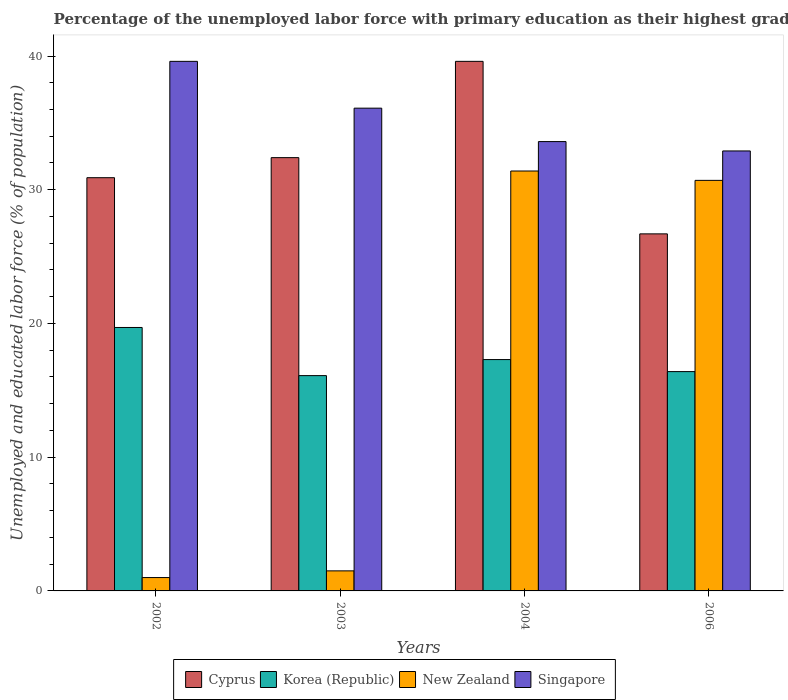How many different coloured bars are there?
Your answer should be compact. 4. How many groups of bars are there?
Your response must be concise. 4. Are the number of bars on each tick of the X-axis equal?
Your answer should be very brief. Yes. How many bars are there on the 1st tick from the right?
Your response must be concise. 4. Across all years, what is the maximum percentage of the unemployed labor force with primary education in New Zealand?
Give a very brief answer. 31.4. Across all years, what is the minimum percentage of the unemployed labor force with primary education in Cyprus?
Your answer should be compact. 26.7. What is the total percentage of the unemployed labor force with primary education in Korea (Republic) in the graph?
Ensure brevity in your answer.  69.5. What is the difference between the percentage of the unemployed labor force with primary education in Singapore in 2002 and that in 2004?
Ensure brevity in your answer.  6. What is the difference between the percentage of the unemployed labor force with primary education in Cyprus in 2003 and the percentage of the unemployed labor force with primary education in New Zealand in 2002?
Provide a short and direct response. 31.4. What is the average percentage of the unemployed labor force with primary education in Cyprus per year?
Make the answer very short. 32.4. In the year 2002, what is the difference between the percentage of the unemployed labor force with primary education in Korea (Republic) and percentage of the unemployed labor force with primary education in Singapore?
Your answer should be compact. -19.9. What is the ratio of the percentage of the unemployed labor force with primary education in Cyprus in 2002 to that in 2006?
Give a very brief answer. 1.16. Is the percentage of the unemployed labor force with primary education in Korea (Republic) in 2002 less than that in 2003?
Offer a terse response. No. Is the difference between the percentage of the unemployed labor force with primary education in Korea (Republic) in 2004 and 2006 greater than the difference between the percentage of the unemployed labor force with primary education in Singapore in 2004 and 2006?
Your response must be concise. Yes. What is the difference between the highest and the second highest percentage of the unemployed labor force with primary education in Korea (Republic)?
Make the answer very short. 2.4. What is the difference between the highest and the lowest percentage of the unemployed labor force with primary education in Cyprus?
Offer a very short reply. 12.9. Is the sum of the percentage of the unemployed labor force with primary education in New Zealand in 2004 and 2006 greater than the maximum percentage of the unemployed labor force with primary education in Korea (Republic) across all years?
Your response must be concise. Yes. Is it the case that in every year, the sum of the percentage of the unemployed labor force with primary education in Cyprus and percentage of the unemployed labor force with primary education in Singapore is greater than the sum of percentage of the unemployed labor force with primary education in Korea (Republic) and percentage of the unemployed labor force with primary education in New Zealand?
Offer a very short reply. No. What does the 4th bar from the left in 2004 represents?
Make the answer very short. Singapore. What does the 4th bar from the right in 2002 represents?
Your answer should be compact. Cyprus. Is it the case that in every year, the sum of the percentage of the unemployed labor force with primary education in Cyprus and percentage of the unemployed labor force with primary education in Korea (Republic) is greater than the percentage of the unemployed labor force with primary education in Singapore?
Give a very brief answer. Yes. How many years are there in the graph?
Keep it short and to the point. 4. Does the graph contain grids?
Make the answer very short. No. How are the legend labels stacked?
Your response must be concise. Horizontal. What is the title of the graph?
Ensure brevity in your answer.  Percentage of the unemployed labor force with primary education as their highest grade. What is the label or title of the Y-axis?
Offer a terse response. Unemployed and educated labor force (% of population). What is the Unemployed and educated labor force (% of population) of Cyprus in 2002?
Make the answer very short. 30.9. What is the Unemployed and educated labor force (% of population) in Korea (Republic) in 2002?
Provide a short and direct response. 19.7. What is the Unemployed and educated labor force (% of population) of New Zealand in 2002?
Offer a terse response. 1. What is the Unemployed and educated labor force (% of population) of Singapore in 2002?
Provide a succinct answer. 39.6. What is the Unemployed and educated labor force (% of population) of Cyprus in 2003?
Offer a very short reply. 32.4. What is the Unemployed and educated labor force (% of population) of Korea (Republic) in 2003?
Your answer should be compact. 16.1. What is the Unemployed and educated labor force (% of population) of Singapore in 2003?
Make the answer very short. 36.1. What is the Unemployed and educated labor force (% of population) in Cyprus in 2004?
Offer a terse response. 39.6. What is the Unemployed and educated labor force (% of population) in Korea (Republic) in 2004?
Provide a succinct answer. 17.3. What is the Unemployed and educated labor force (% of population) of New Zealand in 2004?
Offer a very short reply. 31.4. What is the Unemployed and educated labor force (% of population) in Singapore in 2004?
Your response must be concise. 33.6. What is the Unemployed and educated labor force (% of population) in Cyprus in 2006?
Provide a short and direct response. 26.7. What is the Unemployed and educated labor force (% of population) of Korea (Republic) in 2006?
Give a very brief answer. 16.4. What is the Unemployed and educated labor force (% of population) of New Zealand in 2006?
Give a very brief answer. 30.7. What is the Unemployed and educated labor force (% of population) of Singapore in 2006?
Your response must be concise. 32.9. Across all years, what is the maximum Unemployed and educated labor force (% of population) in Cyprus?
Ensure brevity in your answer.  39.6. Across all years, what is the maximum Unemployed and educated labor force (% of population) in Korea (Republic)?
Your answer should be compact. 19.7. Across all years, what is the maximum Unemployed and educated labor force (% of population) of New Zealand?
Your answer should be compact. 31.4. Across all years, what is the maximum Unemployed and educated labor force (% of population) of Singapore?
Keep it short and to the point. 39.6. Across all years, what is the minimum Unemployed and educated labor force (% of population) of Cyprus?
Give a very brief answer. 26.7. Across all years, what is the minimum Unemployed and educated labor force (% of population) in Korea (Republic)?
Offer a very short reply. 16.1. Across all years, what is the minimum Unemployed and educated labor force (% of population) of Singapore?
Make the answer very short. 32.9. What is the total Unemployed and educated labor force (% of population) in Cyprus in the graph?
Your answer should be very brief. 129.6. What is the total Unemployed and educated labor force (% of population) in Korea (Republic) in the graph?
Your answer should be compact. 69.5. What is the total Unemployed and educated labor force (% of population) of New Zealand in the graph?
Offer a terse response. 64.6. What is the total Unemployed and educated labor force (% of population) of Singapore in the graph?
Your answer should be compact. 142.2. What is the difference between the Unemployed and educated labor force (% of population) in Cyprus in 2002 and that in 2003?
Ensure brevity in your answer.  -1.5. What is the difference between the Unemployed and educated labor force (% of population) in Korea (Republic) in 2002 and that in 2003?
Give a very brief answer. 3.6. What is the difference between the Unemployed and educated labor force (% of population) in Singapore in 2002 and that in 2003?
Offer a very short reply. 3.5. What is the difference between the Unemployed and educated labor force (% of population) of Cyprus in 2002 and that in 2004?
Your response must be concise. -8.7. What is the difference between the Unemployed and educated labor force (% of population) of New Zealand in 2002 and that in 2004?
Offer a very short reply. -30.4. What is the difference between the Unemployed and educated labor force (% of population) in Singapore in 2002 and that in 2004?
Give a very brief answer. 6. What is the difference between the Unemployed and educated labor force (% of population) of Cyprus in 2002 and that in 2006?
Offer a terse response. 4.2. What is the difference between the Unemployed and educated labor force (% of population) in Korea (Republic) in 2002 and that in 2006?
Provide a succinct answer. 3.3. What is the difference between the Unemployed and educated labor force (% of population) of New Zealand in 2002 and that in 2006?
Offer a terse response. -29.7. What is the difference between the Unemployed and educated labor force (% of population) of Singapore in 2002 and that in 2006?
Your answer should be very brief. 6.7. What is the difference between the Unemployed and educated labor force (% of population) in Korea (Republic) in 2003 and that in 2004?
Your answer should be very brief. -1.2. What is the difference between the Unemployed and educated labor force (% of population) in New Zealand in 2003 and that in 2004?
Keep it short and to the point. -29.9. What is the difference between the Unemployed and educated labor force (% of population) in Singapore in 2003 and that in 2004?
Give a very brief answer. 2.5. What is the difference between the Unemployed and educated labor force (% of population) in Cyprus in 2003 and that in 2006?
Ensure brevity in your answer.  5.7. What is the difference between the Unemployed and educated labor force (% of population) in Korea (Republic) in 2003 and that in 2006?
Provide a succinct answer. -0.3. What is the difference between the Unemployed and educated labor force (% of population) in New Zealand in 2003 and that in 2006?
Offer a very short reply. -29.2. What is the difference between the Unemployed and educated labor force (% of population) of Singapore in 2003 and that in 2006?
Make the answer very short. 3.2. What is the difference between the Unemployed and educated labor force (% of population) of Cyprus in 2004 and that in 2006?
Provide a succinct answer. 12.9. What is the difference between the Unemployed and educated labor force (% of population) in New Zealand in 2004 and that in 2006?
Give a very brief answer. 0.7. What is the difference between the Unemployed and educated labor force (% of population) in Cyprus in 2002 and the Unemployed and educated labor force (% of population) in New Zealand in 2003?
Give a very brief answer. 29.4. What is the difference between the Unemployed and educated labor force (% of population) in Korea (Republic) in 2002 and the Unemployed and educated labor force (% of population) in Singapore in 2003?
Give a very brief answer. -16.4. What is the difference between the Unemployed and educated labor force (% of population) of New Zealand in 2002 and the Unemployed and educated labor force (% of population) of Singapore in 2003?
Ensure brevity in your answer.  -35.1. What is the difference between the Unemployed and educated labor force (% of population) of Cyprus in 2002 and the Unemployed and educated labor force (% of population) of Korea (Republic) in 2004?
Provide a short and direct response. 13.6. What is the difference between the Unemployed and educated labor force (% of population) of Cyprus in 2002 and the Unemployed and educated labor force (% of population) of New Zealand in 2004?
Your response must be concise. -0.5. What is the difference between the Unemployed and educated labor force (% of population) in Korea (Republic) in 2002 and the Unemployed and educated labor force (% of population) in New Zealand in 2004?
Your answer should be compact. -11.7. What is the difference between the Unemployed and educated labor force (% of population) in Korea (Republic) in 2002 and the Unemployed and educated labor force (% of population) in Singapore in 2004?
Your response must be concise. -13.9. What is the difference between the Unemployed and educated labor force (% of population) of New Zealand in 2002 and the Unemployed and educated labor force (% of population) of Singapore in 2004?
Make the answer very short. -32.6. What is the difference between the Unemployed and educated labor force (% of population) in Cyprus in 2002 and the Unemployed and educated labor force (% of population) in Korea (Republic) in 2006?
Offer a very short reply. 14.5. What is the difference between the Unemployed and educated labor force (% of population) of Cyprus in 2002 and the Unemployed and educated labor force (% of population) of Singapore in 2006?
Keep it short and to the point. -2. What is the difference between the Unemployed and educated labor force (% of population) of Korea (Republic) in 2002 and the Unemployed and educated labor force (% of population) of New Zealand in 2006?
Give a very brief answer. -11. What is the difference between the Unemployed and educated labor force (% of population) in Korea (Republic) in 2002 and the Unemployed and educated labor force (% of population) in Singapore in 2006?
Provide a short and direct response. -13.2. What is the difference between the Unemployed and educated labor force (% of population) of New Zealand in 2002 and the Unemployed and educated labor force (% of population) of Singapore in 2006?
Ensure brevity in your answer.  -31.9. What is the difference between the Unemployed and educated labor force (% of population) in Cyprus in 2003 and the Unemployed and educated labor force (% of population) in Singapore in 2004?
Provide a succinct answer. -1.2. What is the difference between the Unemployed and educated labor force (% of population) of Korea (Republic) in 2003 and the Unemployed and educated labor force (% of population) of New Zealand in 2004?
Provide a short and direct response. -15.3. What is the difference between the Unemployed and educated labor force (% of population) of Korea (Republic) in 2003 and the Unemployed and educated labor force (% of population) of Singapore in 2004?
Ensure brevity in your answer.  -17.5. What is the difference between the Unemployed and educated labor force (% of population) of New Zealand in 2003 and the Unemployed and educated labor force (% of population) of Singapore in 2004?
Your answer should be compact. -32.1. What is the difference between the Unemployed and educated labor force (% of population) in Cyprus in 2003 and the Unemployed and educated labor force (% of population) in New Zealand in 2006?
Your answer should be compact. 1.7. What is the difference between the Unemployed and educated labor force (% of population) in Cyprus in 2003 and the Unemployed and educated labor force (% of population) in Singapore in 2006?
Offer a terse response. -0.5. What is the difference between the Unemployed and educated labor force (% of population) in Korea (Republic) in 2003 and the Unemployed and educated labor force (% of population) in New Zealand in 2006?
Ensure brevity in your answer.  -14.6. What is the difference between the Unemployed and educated labor force (% of population) in Korea (Republic) in 2003 and the Unemployed and educated labor force (% of population) in Singapore in 2006?
Your answer should be compact. -16.8. What is the difference between the Unemployed and educated labor force (% of population) of New Zealand in 2003 and the Unemployed and educated labor force (% of population) of Singapore in 2006?
Make the answer very short. -31.4. What is the difference between the Unemployed and educated labor force (% of population) of Cyprus in 2004 and the Unemployed and educated labor force (% of population) of Korea (Republic) in 2006?
Provide a succinct answer. 23.2. What is the difference between the Unemployed and educated labor force (% of population) of Cyprus in 2004 and the Unemployed and educated labor force (% of population) of New Zealand in 2006?
Make the answer very short. 8.9. What is the difference between the Unemployed and educated labor force (% of population) in Korea (Republic) in 2004 and the Unemployed and educated labor force (% of population) in Singapore in 2006?
Offer a terse response. -15.6. What is the difference between the Unemployed and educated labor force (% of population) of New Zealand in 2004 and the Unemployed and educated labor force (% of population) of Singapore in 2006?
Ensure brevity in your answer.  -1.5. What is the average Unemployed and educated labor force (% of population) in Cyprus per year?
Give a very brief answer. 32.4. What is the average Unemployed and educated labor force (% of population) of Korea (Republic) per year?
Your answer should be very brief. 17.38. What is the average Unemployed and educated labor force (% of population) in New Zealand per year?
Offer a very short reply. 16.15. What is the average Unemployed and educated labor force (% of population) in Singapore per year?
Your answer should be very brief. 35.55. In the year 2002, what is the difference between the Unemployed and educated labor force (% of population) of Cyprus and Unemployed and educated labor force (% of population) of New Zealand?
Offer a terse response. 29.9. In the year 2002, what is the difference between the Unemployed and educated labor force (% of population) of Cyprus and Unemployed and educated labor force (% of population) of Singapore?
Ensure brevity in your answer.  -8.7. In the year 2002, what is the difference between the Unemployed and educated labor force (% of population) of Korea (Republic) and Unemployed and educated labor force (% of population) of New Zealand?
Your answer should be compact. 18.7. In the year 2002, what is the difference between the Unemployed and educated labor force (% of population) of Korea (Republic) and Unemployed and educated labor force (% of population) of Singapore?
Keep it short and to the point. -19.9. In the year 2002, what is the difference between the Unemployed and educated labor force (% of population) in New Zealand and Unemployed and educated labor force (% of population) in Singapore?
Your response must be concise. -38.6. In the year 2003, what is the difference between the Unemployed and educated labor force (% of population) of Cyprus and Unemployed and educated labor force (% of population) of Korea (Republic)?
Provide a succinct answer. 16.3. In the year 2003, what is the difference between the Unemployed and educated labor force (% of population) in Cyprus and Unemployed and educated labor force (% of population) in New Zealand?
Provide a succinct answer. 30.9. In the year 2003, what is the difference between the Unemployed and educated labor force (% of population) of Cyprus and Unemployed and educated labor force (% of population) of Singapore?
Offer a terse response. -3.7. In the year 2003, what is the difference between the Unemployed and educated labor force (% of population) of Korea (Republic) and Unemployed and educated labor force (% of population) of New Zealand?
Provide a short and direct response. 14.6. In the year 2003, what is the difference between the Unemployed and educated labor force (% of population) in Korea (Republic) and Unemployed and educated labor force (% of population) in Singapore?
Offer a terse response. -20. In the year 2003, what is the difference between the Unemployed and educated labor force (% of population) of New Zealand and Unemployed and educated labor force (% of population) of Singapore?
Provide a succinct answer. -34.6. In the year 2004, what is the difference between the Unemployed and educated labor force (% of population) in Cyprus and Unemployed and educated labor force (% of population) in Korea (Republic)?
Offer a terse response. 22.3. In the year 2004, what is the difference between the Unemployed and educated labor force (% of population) in Korea (Republic) and Unemployed and educated labor force (% of population) in New Zealand?
Offer a terse response. -14.1. In the year 2004, what is the difference between the Unemployed and educated labor force (% of population) in Korea (Republic) and Unemployed and educated labor force (% of population) in Singapore?
Give a very brief answer. -16.3. In the year 2004, what is the difference between the Unemployed and educated labor force (% of population) of New Zealand and Unemployed and educated labor force (% of population) of Singapore?
Offer a terse response. -2.2. In the year 2006, what is the difference between the Unemployed and educated labor force (% of population) in Cyprus and Unemployed and educated labor force (% of population) in Korea (Republic)?
Offer a terse response. 10.3. In the year 2006, what is the difference between the Unemployed and educated labor force (% of population) of Cyprus and Unemployed and educated labor force (% of population) of Singapore?
Make the answer very short. -6.2. In the year 2006, what is the difference between the Unemployed and educated labor force (% of population) in Korea (Republic) and Unemployed and educated labor force (% of population) in New Zealand?
Make the answer very short. -14.3. In the year 2006, what is the difference between the Unemployed and educated labor force (% of population) in Korea (Republic) and Unemployed and educated labor force (% of population) in Singapore?
Give a very brief answer. -16.5. In the year 2006, what is the difference between the Unemployed and educated labor force (% of population) in New Zealand and Unemployed and educated labor force (% of population) in Singapore?
Your answer should be compact. -2.2. What is the ratio of the Unemployed and educated labor force (% of population) of Cyprus in 2002 to that in 2003?
Keep it short and to the point. 0.95. What is the ratio of the Unemployed and educated labor force (% of population) of Korea (Republic) in 2002 to that in 2003?
Offer a very short reply. 1.22. What is the ratio of the Unemployed and educated labor force (% of population) in Singapore in 2002 to that in 2003?
Your answer should be compact. 1.1. What is the ratio of the Unemployed and educated labor force (% of population) in Cyprus in 2002 to that in 2004?
Give a very brief answer. 0.78. What is the ratio of the Unemployed and educated labor force (% of population) of Korea (Republic) in 2002 to that in 2004?
Provide a short and direct response. 1.14. What is the ratio of the Unemployed and educated labor force (% of population) in New Zealand in 2002 to that in 2004?
Offer a terse response. 0.03. What is the ratio of the Unemployed and educated labor force (% of population) of Singapore in 2002 to that in 2004?
Provide a short and direct response. 1.18. What is the ratio of the Unemployed and educated labor force (% of population) of Cyprus in 2002 to that in 2006?
Keep it short and to the point. 1.16. What is the ratio of the Unemployed and educated labor force (% of population) in Korea (Republic) in 2002 to that in 2006?
Give a very brief answer. 1.2. What is the ratio of the Unemployed and educated labor force (% of population) in New Zealand in 2002 to that in 2006?
Provide a short and direct response. 0.03. What is the ratio of the Unemployed and educated labor force (% of population) in Singapore in 2002 to that in 2006?
Offer a terse response. 1.2. What is the ratio of the Unemployed and educated labor force (% of population) of Cyprus in 2003 to that in 2004?
Provide a short and direct response. 0.82. What is the ratio of the Unemployed and educated labor force (% of population) in Korea (Republic) in 2003 to that in 2004?
Give a very brief answer. 0.93. What is the ratio of the Unemployed and educated labor force (% of population) in New Zealand in 2003 to that in 2004?
Offer a terse response. 0.05. What is the ratio of the Unemployed and educated labor force (% of population) in Singapore in 2003 to that in 2004?
Your answer should be compact. 1.07. What is the ratio of the Unemployed and educated labor force (% of population) of Cyprus in 2003 to that in 2006?
Provide a short and direct response. 1.21. What is the ratio of the Unemployed and educated labor force (% of population) of Korea (Republic) in 2003 to that in 2006?
Your answer should be compact. 0.98. What is the ratio of the Unemployed and educated labor force (% of population) of New Zealand in 2003 to that in 2006?
Keep it short and to the point. 0.05. What is the ratio of the Unemployed and educated labor force (% of population) in Singapore in 2003 to that in 2006?
Keep it short and to the point. 1.1. What is the ratio of the Unemployed and educated labor force (% of population) of Cyprus in 2004 to that in 2006?
Your response must be concise. 1.48. What is the ratio of the Unemployed and educated labor force (% of population) in Korea (Republic) in 2004 to that in 2006?
Your answer should be compact. 1.05. What is the ratio of the Unemployed and educated labor force (% of population) of New Zealand in 2004 to that in 2006?
Offer a very short reply. 1.02. What is the ratio of the Unemployed and educated labor force (% of population) in Singapore in 2004 to that in 2006?
Offer a terse response. 1.02. What is the difference between the highest and the second highest Unemployed and educated labor force (% of population) of New Zealand?
Provide a succinct answer. 0.7. What is the difference between the highest and the lowest Unemployed and educated labor force (% of population) of Korea (Republic)?
Provide a succinct answer. 3.6. What is the difference between the highest and the lowest Unemployed and educated labor force (% of population) in New Zealand?
Offer a terse response. 30.4. What is the difference between the highest and the lowest Unemployed and educated labor force (% of population) of Singapore?
Make the answer very short. 6.7. 